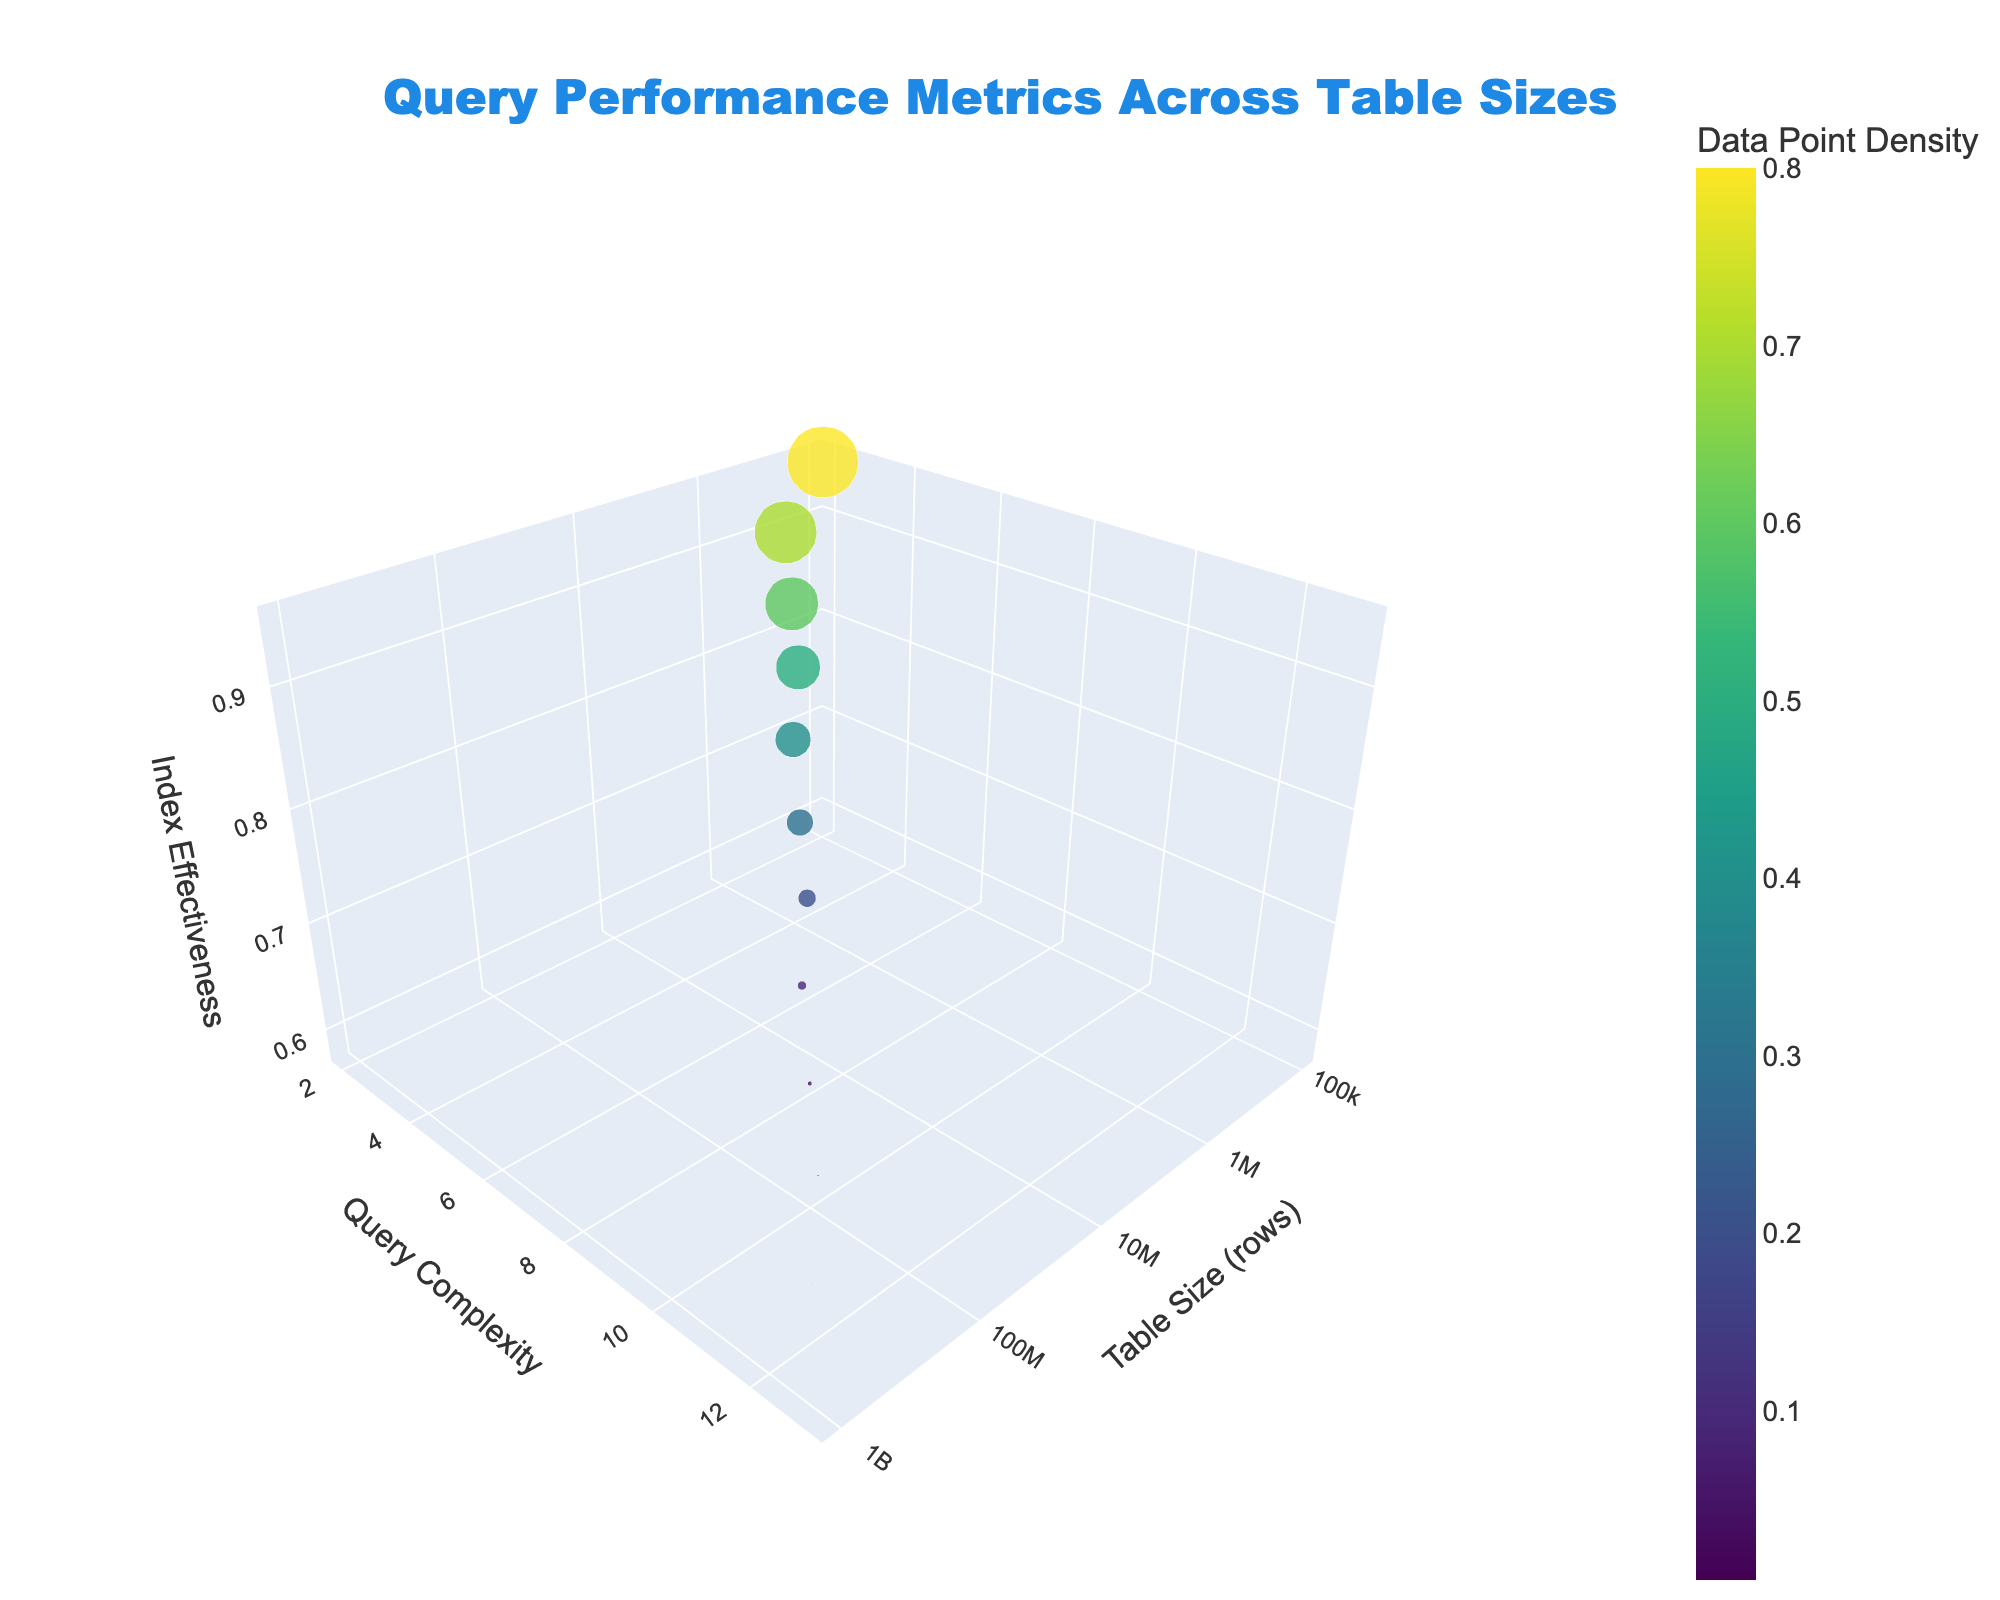what is the title of the plot? You can find the plot's title at the top of the figure. It reads "Query Performance Metrics Across Table Sizes".
Answer: Query Performance Metrics Across Table Sizes What is the x-axis title? The x-axis title is "Table Size (rows)", which indicates that the x-axis represents the size of the table in terms of rows.
Answer: Table Size (rows) Which data point has the highest index effectiveness? To find the highest index effectiveness, look at the z-axis and identify the point with the maximum z-value. The highest index effectiveness is 0.95, corresponding to the data point with a table size of 100,000 rows.
Answer: Table size of 100,000 rows What is the relationship between query complexity and table size? By observing the y-axis (query complexity) and the x-axis (table size) together, we can see that as the table size increases, the query complexity also increases. This is evident because the data points move up in the y-axis as they move right in the x-axis.
Answer: Query complexity increases with table size How does data point density change with increasing table size? Data point density is represented by both the color and the size of the markers. As the table size increases along the x-axis, the density decreases, indicated by markers getting smaller and changing to darker colors on the color scale.
Answer: Data point density decreases with table size Compare the index effectiveness for table sizes of 100,000 and 10,000,000 rows. By examining the z-axis (index effectiveness) for table sizes of 100,000 and 10,000,000 rows, we find that the index effectiveness is 0.95 for 100,000 rows and 0.78 for 10,000,000 rows.
Answer: 0.95 is higher than 0.78 What can you infer about the query complexity for the smallest and largest table sizes? The smallest table size is 100,000 rows and the largest is 1,000,000,000 rows. Their query complexities are 2 and 13, respectively. This indicates that query complexity increases with table size.
Answer: Query complexity increases with table size What is the average index effectiveness across all data points? To find the average index effectiveness, add all the z-values (index effectiveness) and divide by the number of points: (0.95 + 0.92 + 0.88 + 0.85 + 0.82 + 0.78 + 0.75 + 0.72 + 0.68 + 0.65 + 0.62 + 0.58) / 12 = 0.77
Answer: 0.77 Identify the data point with the lowest data point density. What is its table size? The data point with the lowest data point density has the smallest marker and the darkest color. This corresponds to a data point density of 0.005, which occurs at a table size of 1,000,000,000 rows.
Answer: 1,000,000,000 rows 